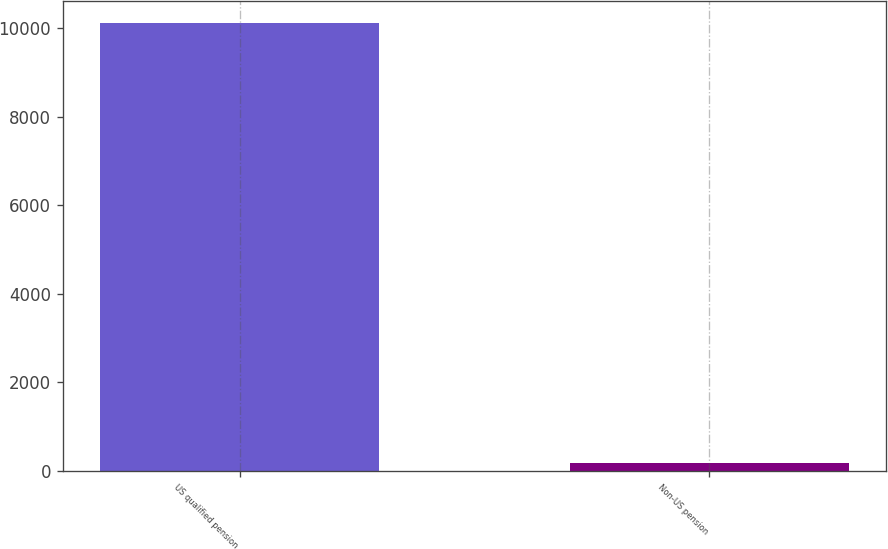Convert chart. <chart><loc_0><loc_0><loc_500><loc_500><bar_chart><fcel>US qualified pension<fcel>Non-US pension<nl><fcel>10111<fcel>171<nl></chart> 